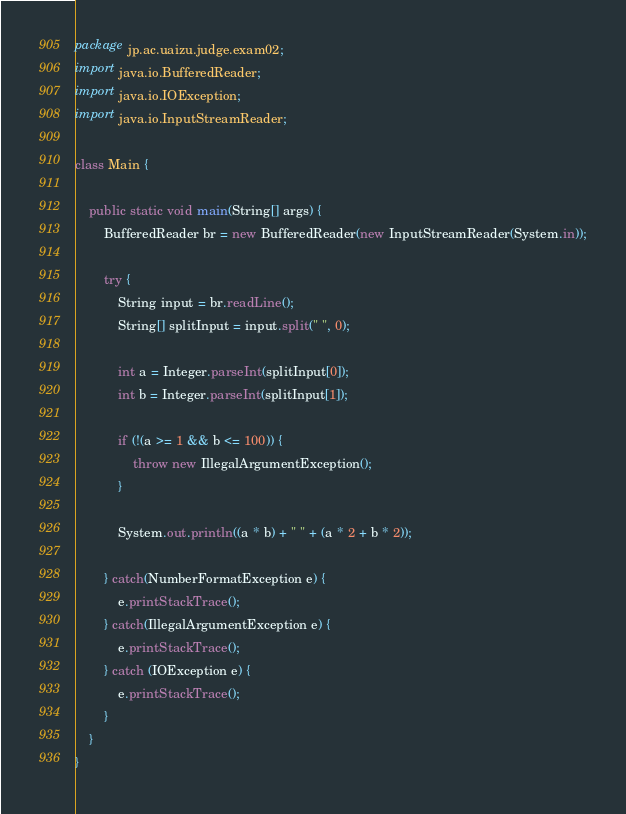<code> <loc_0><loc_0><loc_500><loc_500><_Java_>package jp.ac.uaizu.judge.exam02;
import java.io.BufferedReader;
import java.io.IOException;
import java.io.InputStreamReader;

class Main {

	public static void main(String[] args) {
		BufferedReader br = new BufferedReader(new InputStreamReader(System.in));
		
		try {
			String input = br.readLine();
			String[] splitInput = input.split(" ", 0);

			int a = Integer.parseInt(splitInput[0]);
			int b = Integer.parseInt(splitInput[1]);
			
			if (!(a >= 1 && b <= 100)) {
				throw new IllegalArgumentException();
			}
			
			System.out.println((a * b) + " " + (a * 2 + b * 2));
		
		} catch(NumberFormatException e) {
			e.printStackTrace();
		} catch(IllegalArgumentException e) {
			e.printStackTrace();
		} catch (IOException e) {
			e.printStackTrace();
		}
	}
}</code> 